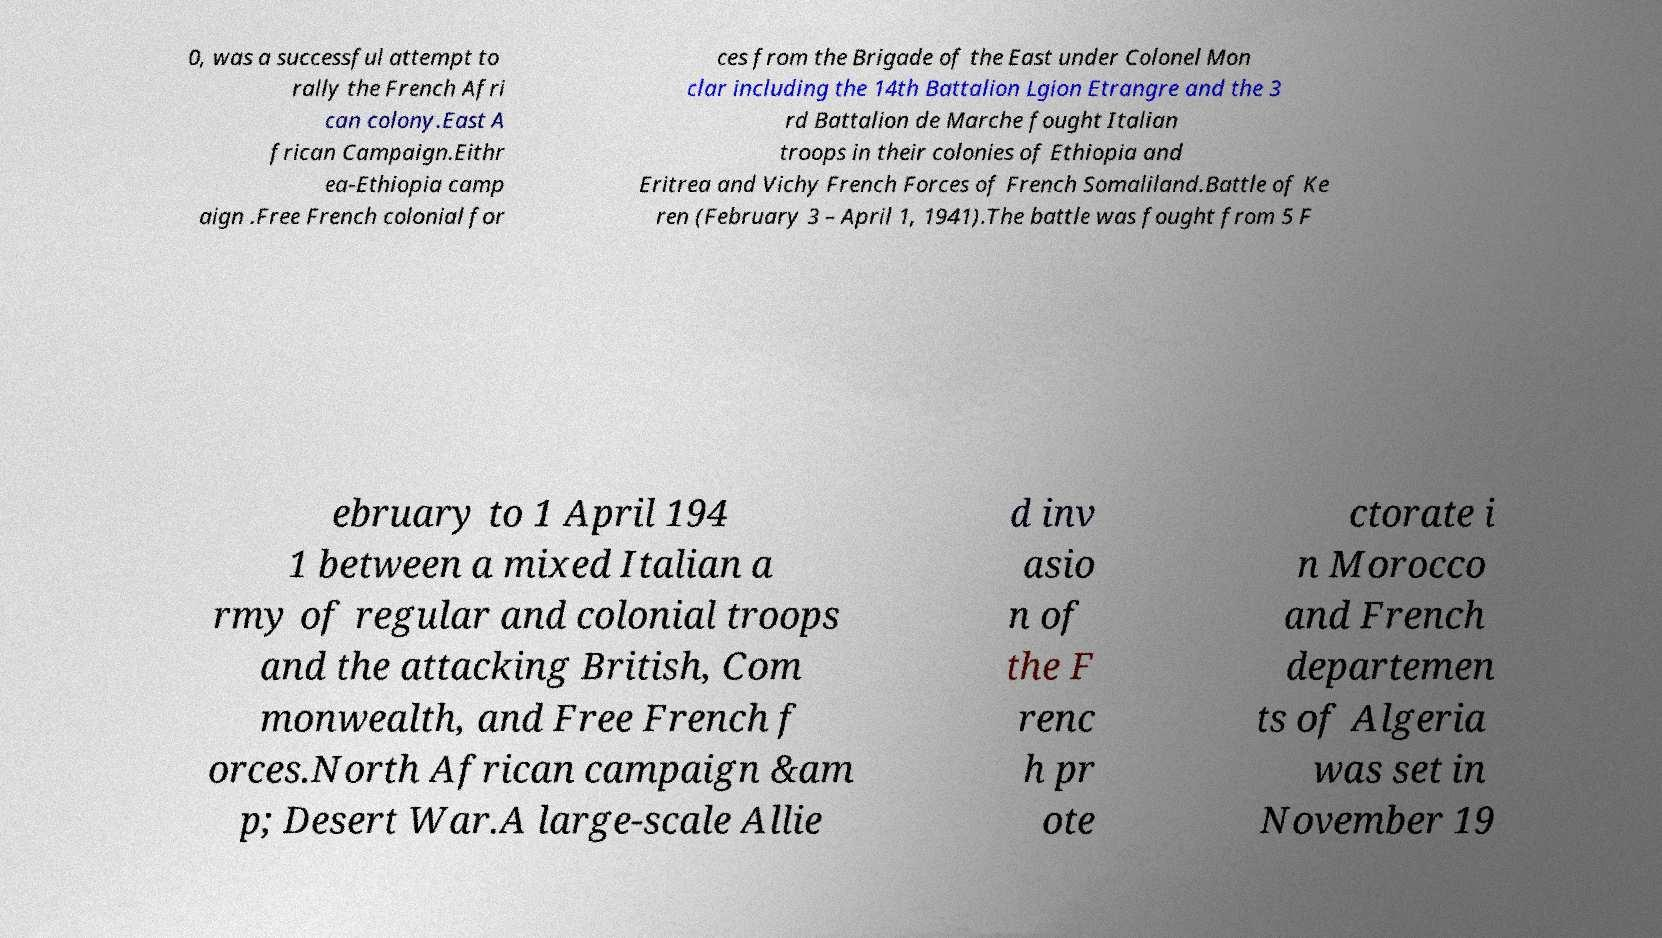Please read and relay the text visible in this image. What does it say? 0, was a successful attempt to rally the French Afri can colony.East A frican Campaign.Eithr ea-Ethiopia camp aign .Free French colonial for ces from the Brigade of the East under Colonel Mon clar including the 14th Battalion Lgion Etrangre and the 3 rd Battalion de Marche fought Italian troops in their colonies of Ethiopia and Eritrea and Vichy French Forces of French Somaliland.Battle of Ke ren (February 3 – April 1, 1941).The battle was fought from 5 F ebruary to 1 April 194 1 between a mixed Italian a rmy of regular and colonial troops and the attacking British, Com monwealth, and Free French f orces.North African campaign &am p; Desert War.A large-scale Allie d inv asio n of the F renc h pr ote ctorate i n Morocco and French departemen ts of Algeria was set in November 19 